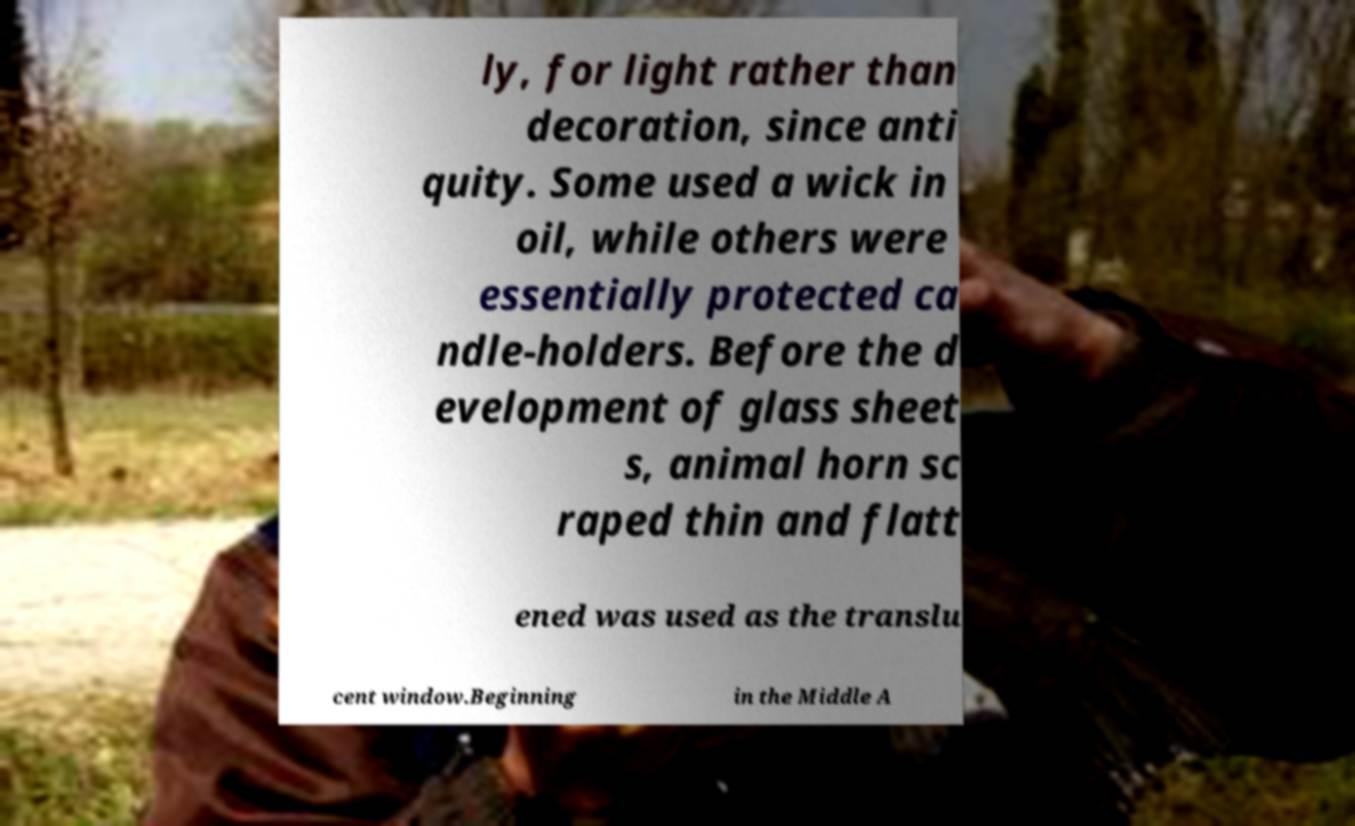What messages or text are displayed in this image? I need them in a readable, typed format. ly, for light rather than decoration, since anti quity. Some used a wick in oil, while others were essentially protected ca ndle-holders. Before the d evelopment of glass sheet s, animal horn sc raped thin and flatt ened was used as the translu cent window.Beginning in the Middle A 